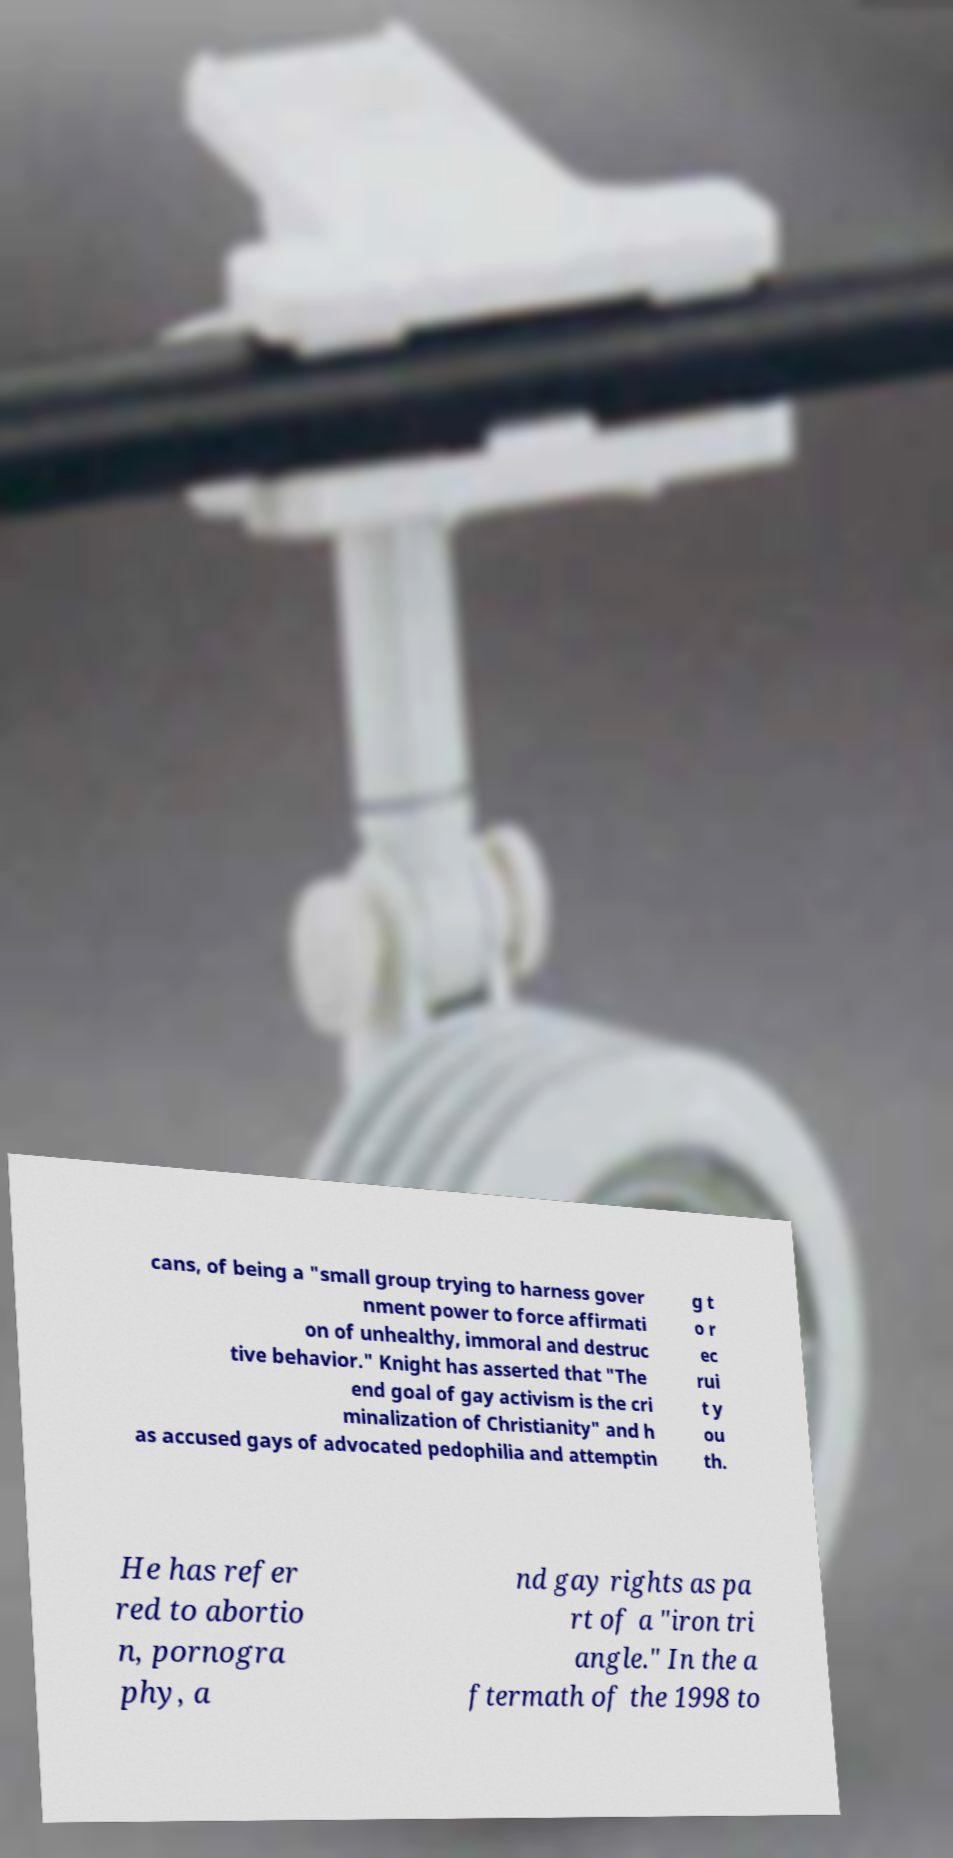There's text embedded in this image that I need extracted. Can you transcribe it verbatim? cans, of being a "small group trying to harness gover nment power to force affirmati on of unhealthy, immoral and destruc tive behavior." Knight has asserted that "The end goal of gay activism is the cri minalization of Christianity" and h as accused gays of advocated pedophilia and attemptin g t o r ec rui t y ou th. He has refer red to abortio n, pornogra phy, a nd gay rights as pa rt of a "iron tri angle." In the a ftermath of the 1998 to 